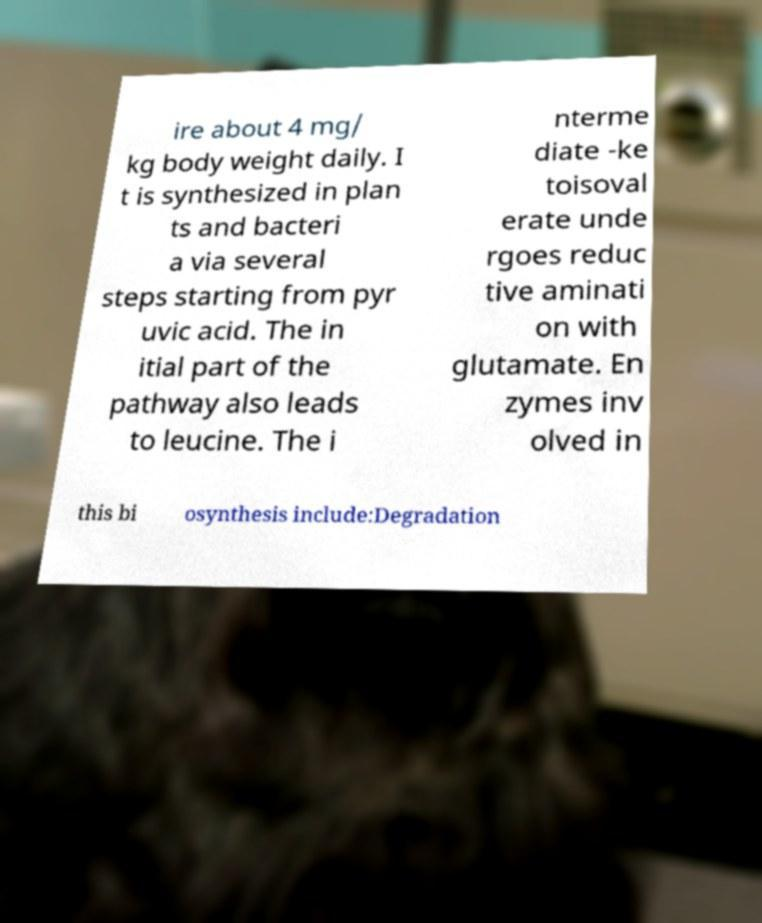Could you extract and type out the text from this image? ire about 4 mg/ kg body weight daily. I t is synthesized in plan ts and bacteri a via several steps starting from pyr uvic acid. The in itial part of the pathway also leads to leucine. The i nterme diate -ke toisoval erate unde rgoes reduc tive aminati on with glutamate. En zymes inv olved in this bi osynthesis include:Degradation 